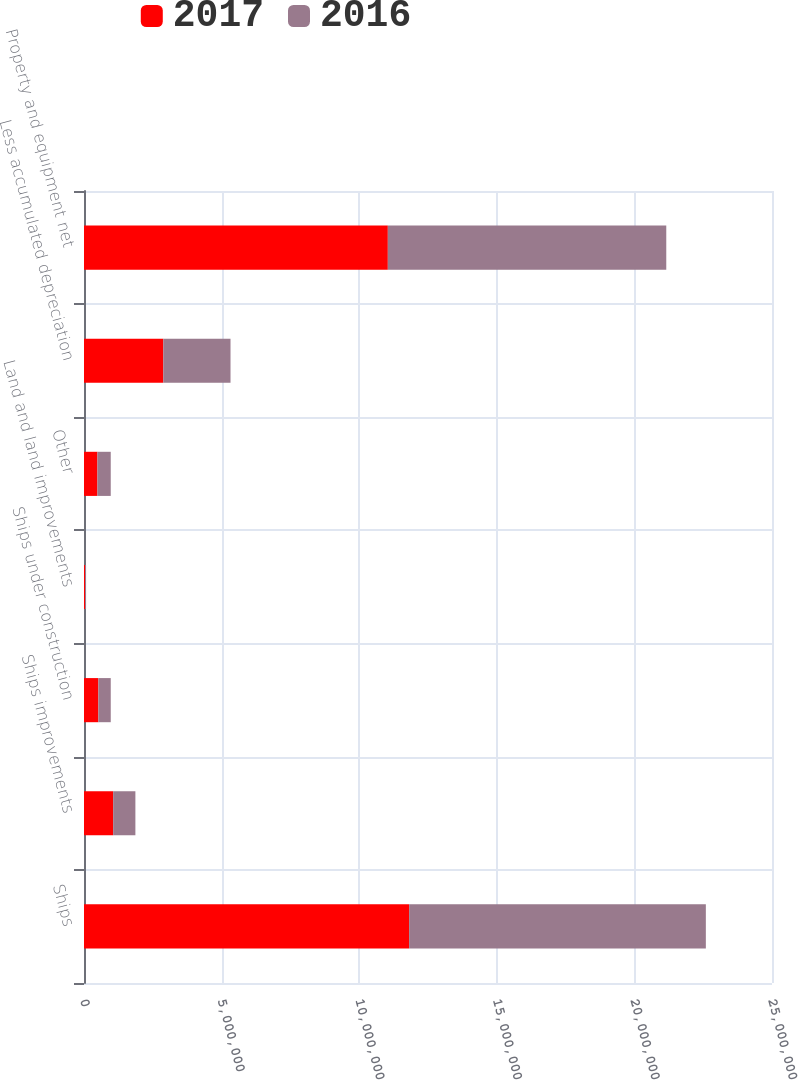<chart> <loc_0><loc_0><loc_500><loc_500><stacked_bar_chart><ecel><fcel>Ships<fcel>Ships improvements<fcel>Ships under construction<fcel>Land and land improvements<fcel>Other<fcel>Less accumulated depreciation<fcel>Property and equipment net<nl><fcel>2017<fcel>1.18144e+07<fcel>1.06005e+06<fcel>521597<fcel>37535<fcel>487921<fcel>2.88102e+06<fcel>1.10405e+07<nl><fcel>2016<fcel>1.07817e+07<fcel>807233<fcel>450372<fcel>37535<fcel>483744<fcel>2.4429e+06<fcel>1.01177e+07<nl></chart> 